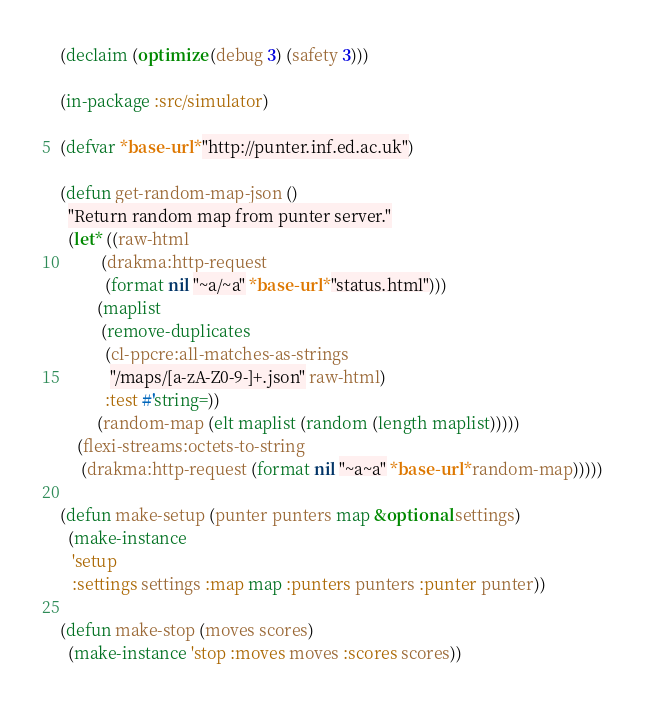Convert code to text. <code><loc_0><loc_0><loc_500><loc_500><_Lisp_>
(declaim (optimize (debug 3) (safety 3)))

(in-package :src/simulator)

(defvar *base-url* "http://punter.inf.ed.ac.uk")

(defun get-random-map-json ()
  "Return random map from punter server."
  (let* ((raw-html
          (drakma:http-request
           (format nil "~a/~a" *base-url* "status.html")))
         (maplist
          (remove-duplicates
           (cl-ppcre:all-matches-as-strings
            "/maps/[a-zA-Z0-9-]+.json" raw-html)
           :test #'string=))
         (random-map (elt maplist (random (length maplist)))))
    (flexi-streams:octets-to-string
     (drakma:http-request (format nil "~a~a" *base-url* random-map)))))

(defun make-setup (punter punters map &optional settings)
  (make-instance
   'setup
   :settings settings :map map :punters punters :punter punter))

(defun make-stop (moves scores)
  (make-instance 'stop :moves moves :scores scores))
</code> 